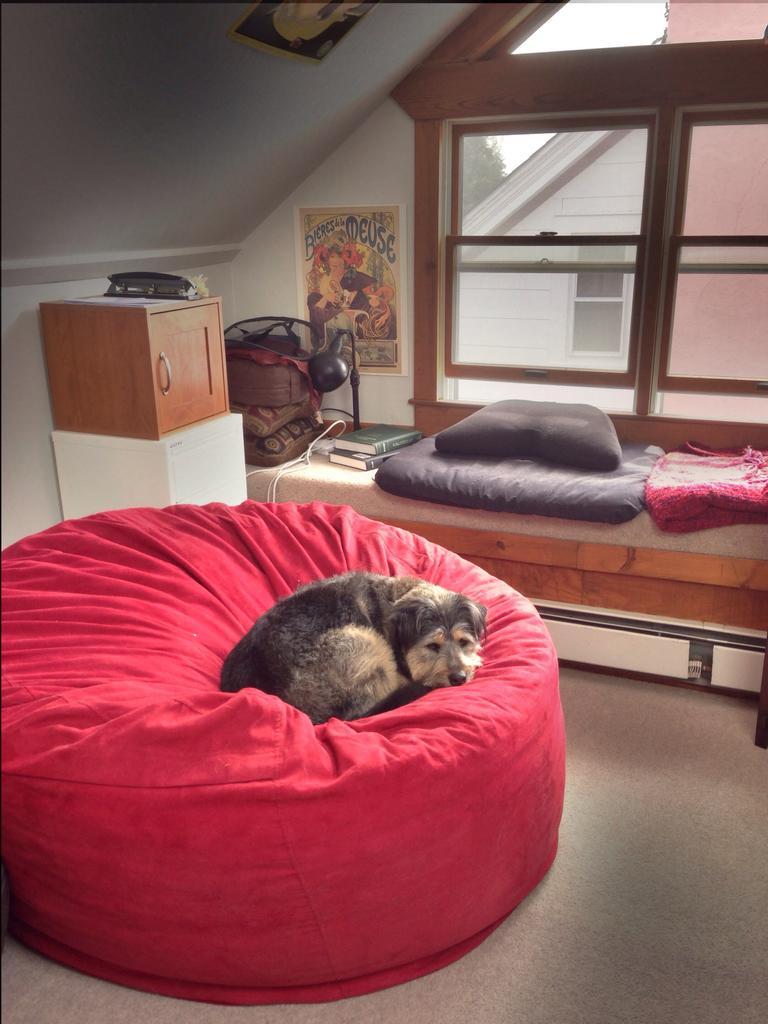In one or two sentences, can you explain what this image depicts? In the image I can see dog sitting on the bean bag, beside that there are some cupboards and bed with pillow, blanket, books and lamp, also there is a window in between the walls. 